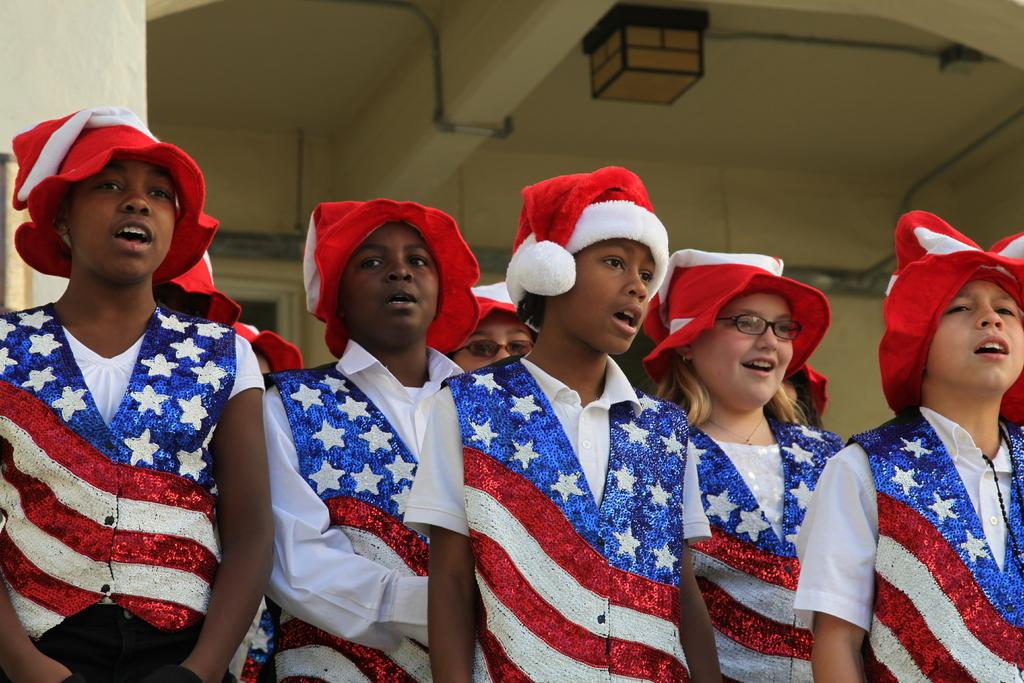What is the main subject of the image? The main subject of the image is a group of people. What are the people wearing in the image? The people are wearing red, white, and blue color dresses and caps. What can be seen in the background of the image? There is a wall in the background of the image. What type of current can be seen flowing through the people in the image? There is no current visible in the image; it features a group of people wearing red, white, and blue color dresses and caps with a wall in the background. 